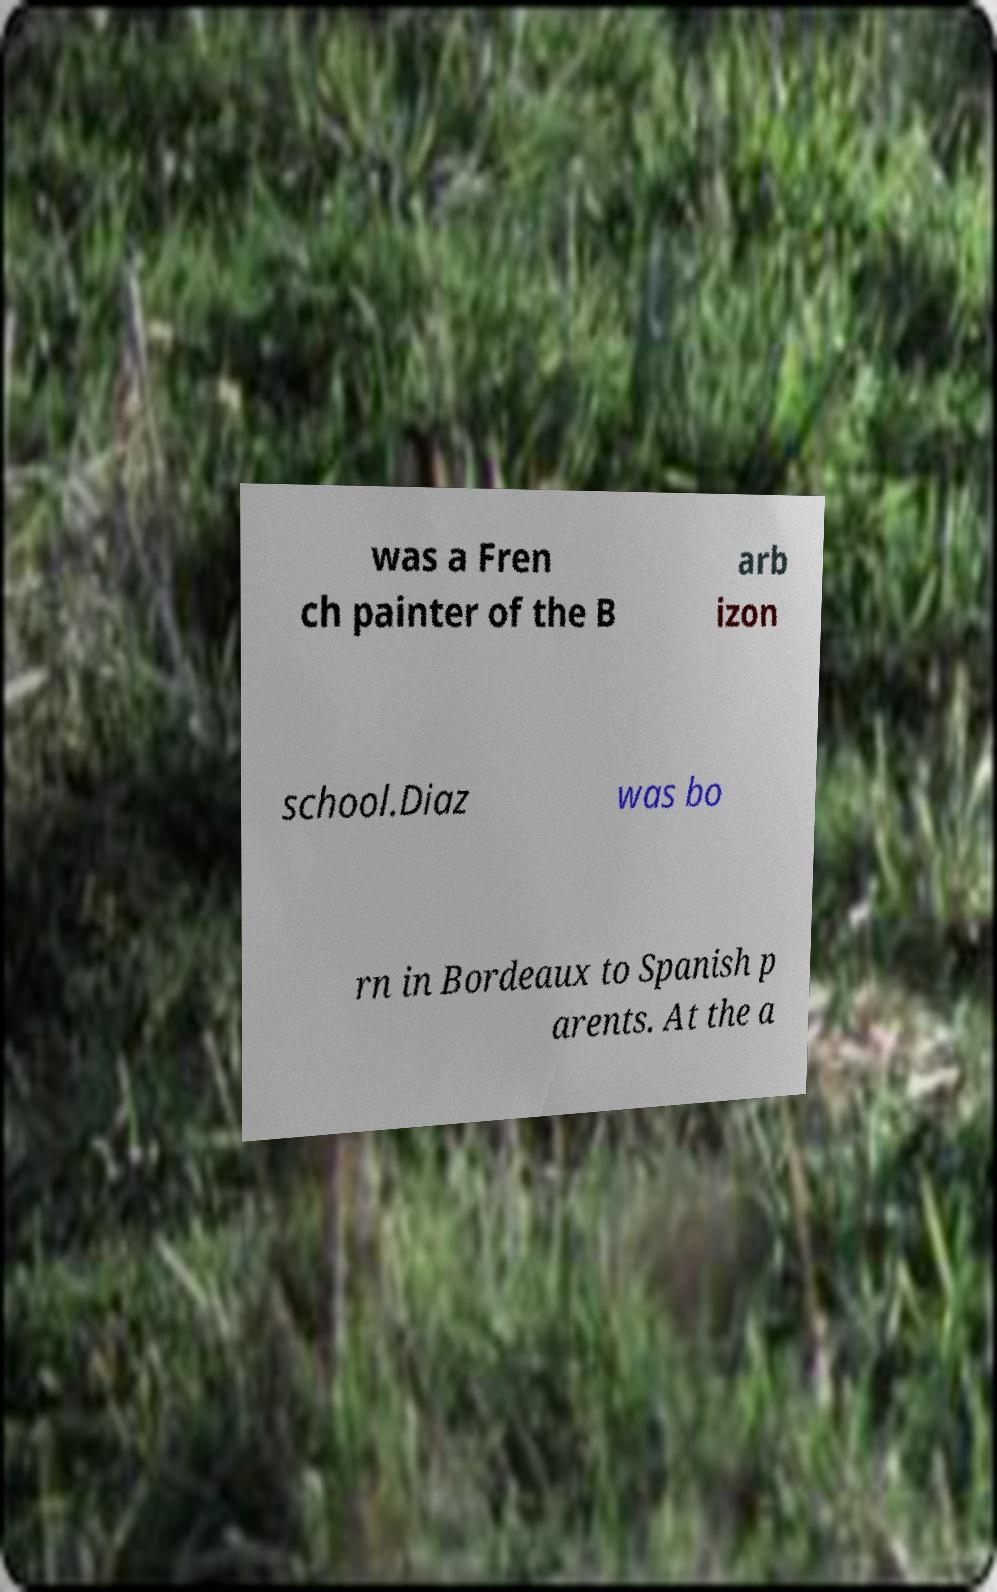Please read and relay the text visible in this image. What does it say? was a Fren ch painter of the B arb izon school.Diaz was bo rn in Bordeaux to Spanish p arents. At the a 